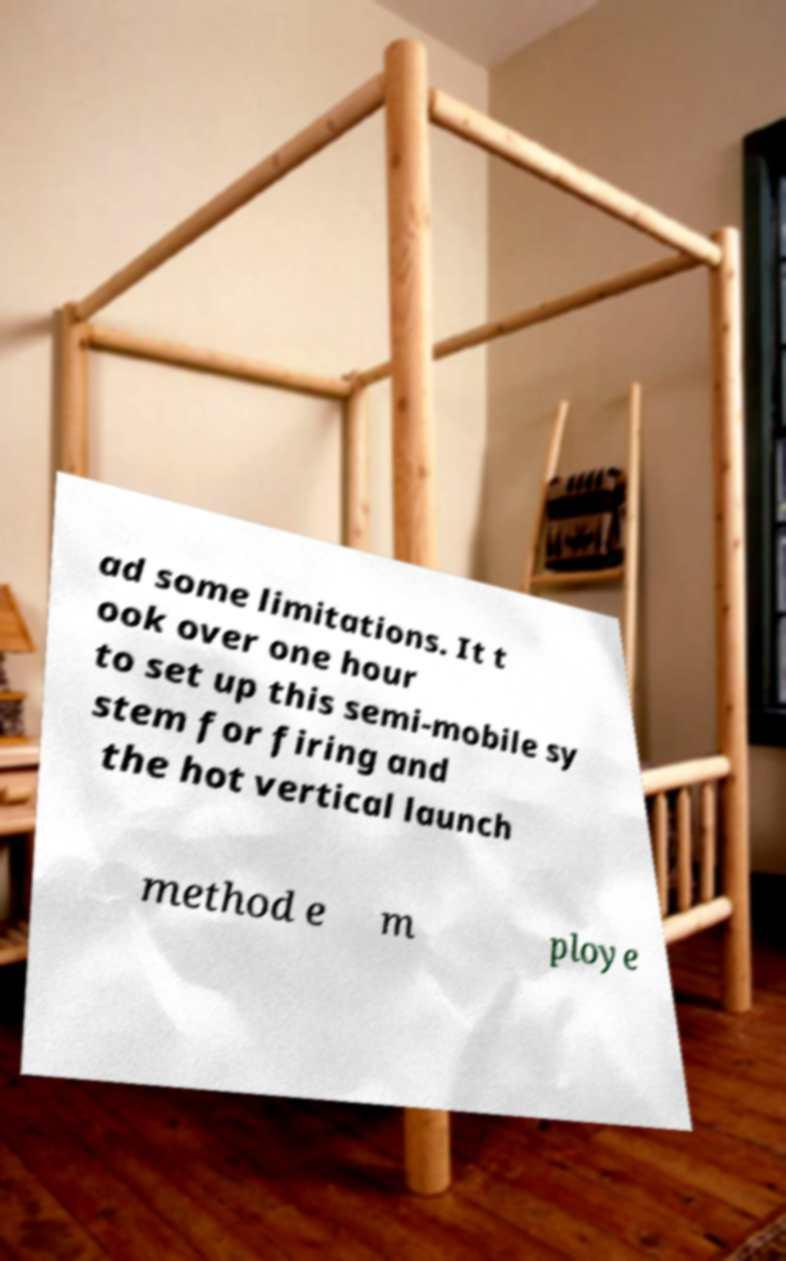Could you assist in decoding the text presented in this image and type it out clearly? ad some limitations. It t ook over one hour to set up this semi-mobile sy stem for firing and the hot vertical launch method e m ploye 